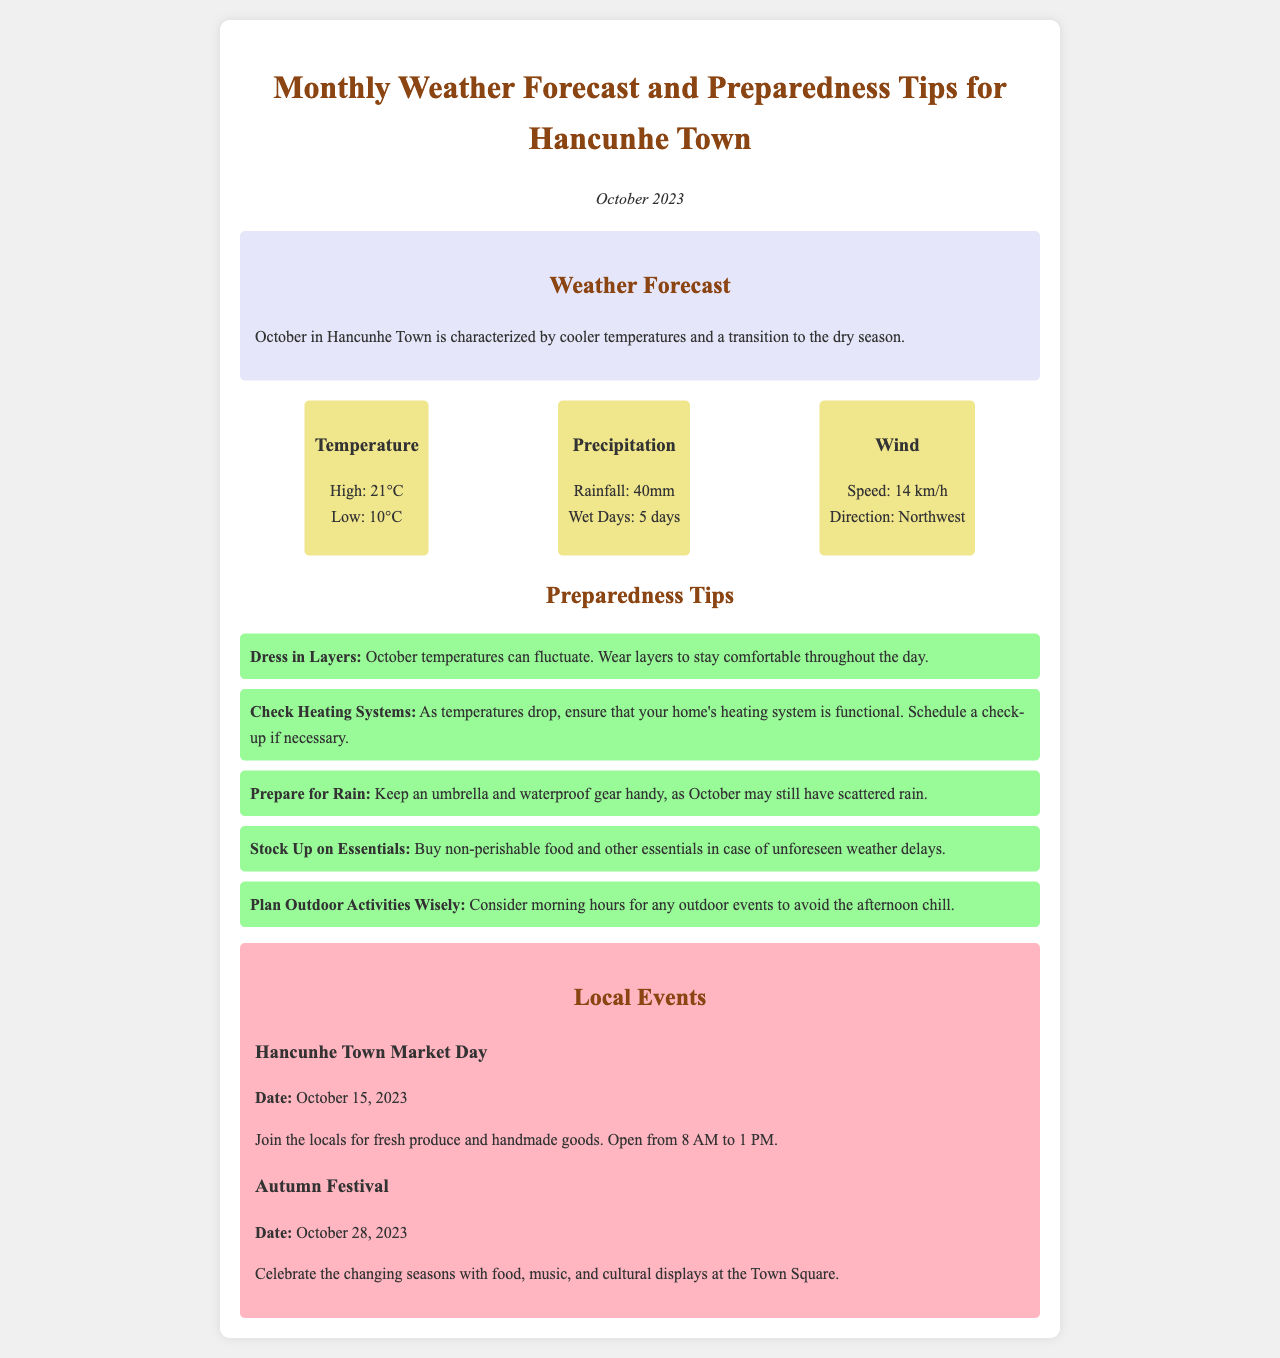What are the high and low temperatures for October? The high and low temperatures for October are specified in the weather details section of the document.
Answer: 21°C, 10°C How much rainfall is expected in October? The document provides information on rainfall in the precipitation section.
Answer: 40mm How many days of rain are predicted? This information is included in the precipitation details provided in the weather section.
Answer: 5 days What should you prepare to handle rain? This is a specific preparedness tip mentioned in the tips list for dealing with rain.
Answer: Umbrella and waterproof gear When is the Hancunhe Town Market Day? The date of the market day is specified in the local events section of the newsletter.
Answer: October 15, 2023 What is the temperature direction for wind in October? This detail is found under the weather details about wind in the newsletter.
Answer: Northwest What is a suggested time for outdoor activities? The tips for planning outdoor activities mention specific timing to avoid chill.
Answer: Morning What type of festival is mentioned in the local events? This information is categorized under local events in the newsletter.
Answer: Autumn Festival 